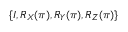Convert formula to latex. <formula><loc_0><loc_0><loc_500><loc_500>\{ I , R _ { X } ( \pi ) , R _ { Y } ( \pi ) , R _ { Z } ( \pi ) \}</formula> 